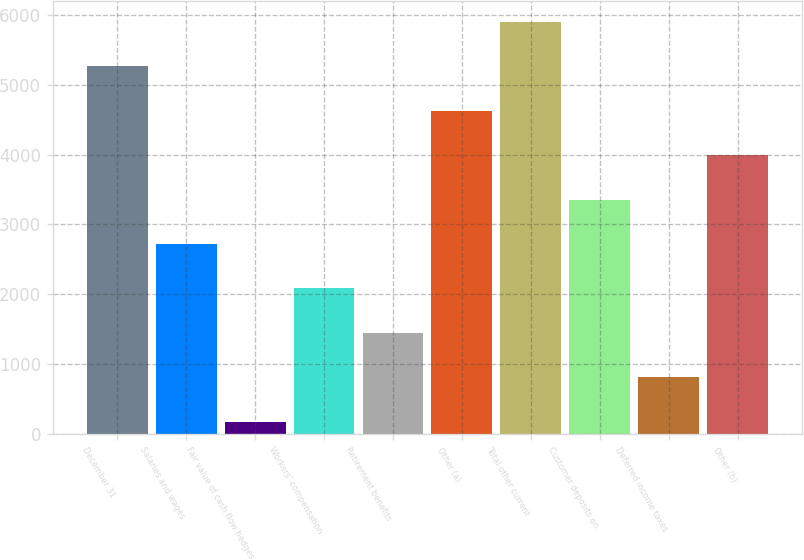<chart> <loc_0><loc_0><loc_500><loc_500><bar_chart><fcel>December 31<fcel>Salaries and wages<fcel>Fair value of cash flow hedges<fcel>Workers' compensation<fcel>Retirement benefits<fcel>Other (a)<fcel>Total other current<fcel>Customer deposits on<fcel>Deferred income taxes<fcel>Other (b)<nl><fcel>5261.6<fcel>2720.8<fcel>180<fcel>2085.6<fcel>1450.4<fcel>4626.4<fcel>5896.8<fcel>3356<fcel>815.2<fcel>3991.2<nl></chart> 